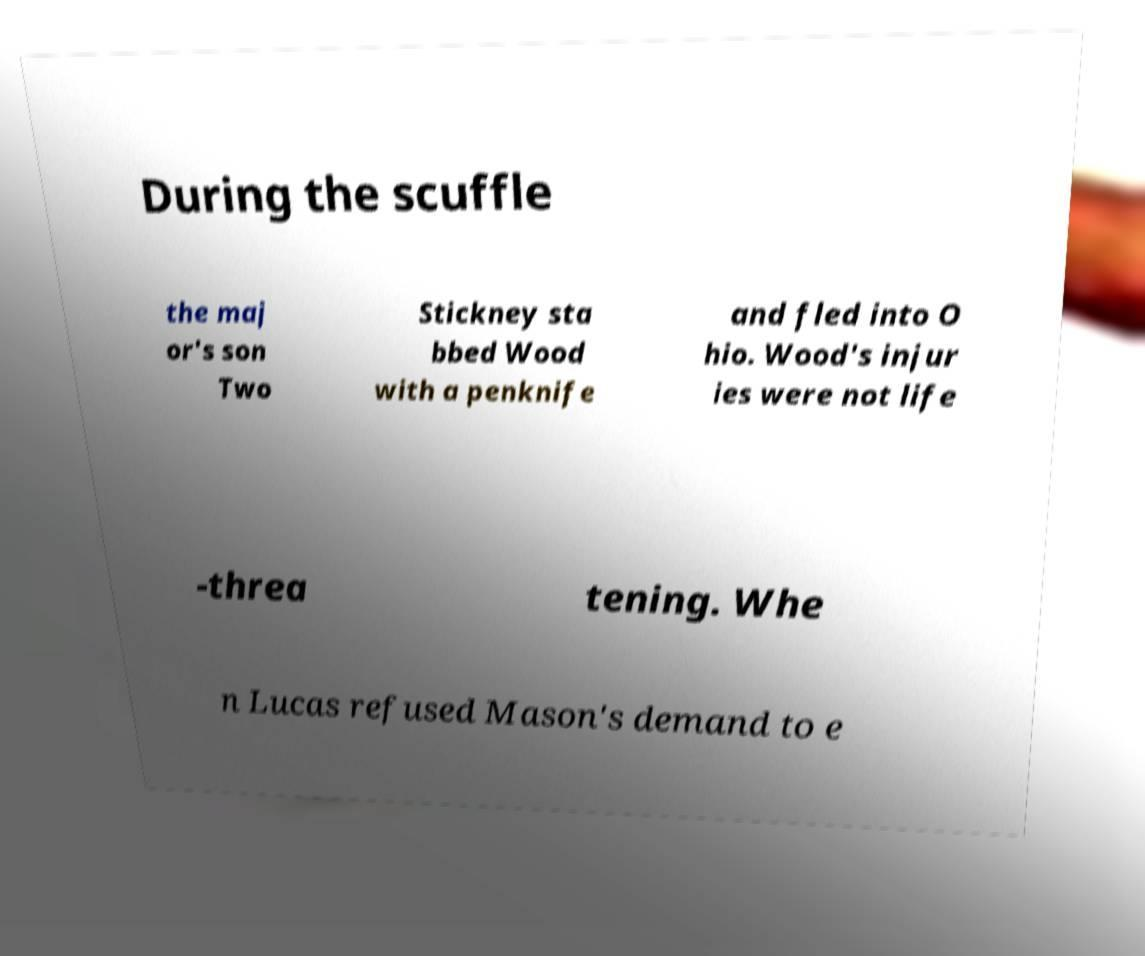I need the written content from this picture converted into text. Can you do that? During the scuffle the maj or's son Two Stickney sta bbed Wood with a penknife and fled into O hio. Wood's injur ies were not life -threa tening. Whe n Lucas refused Mason's demand to e 